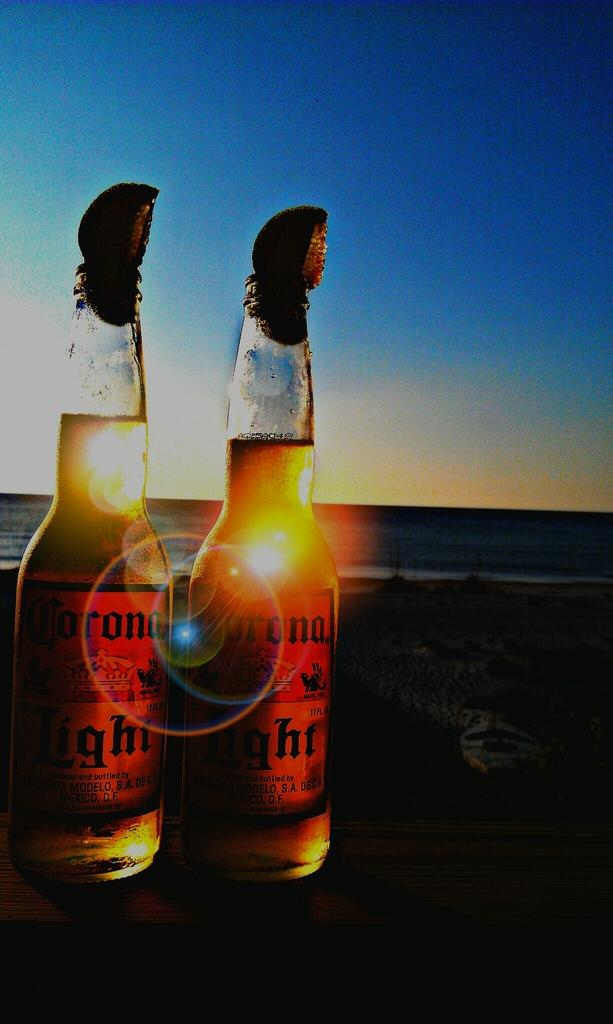<image>
Render a clear and concise summary of the photo. Two bottles of beer called Corona Light next to each other. 